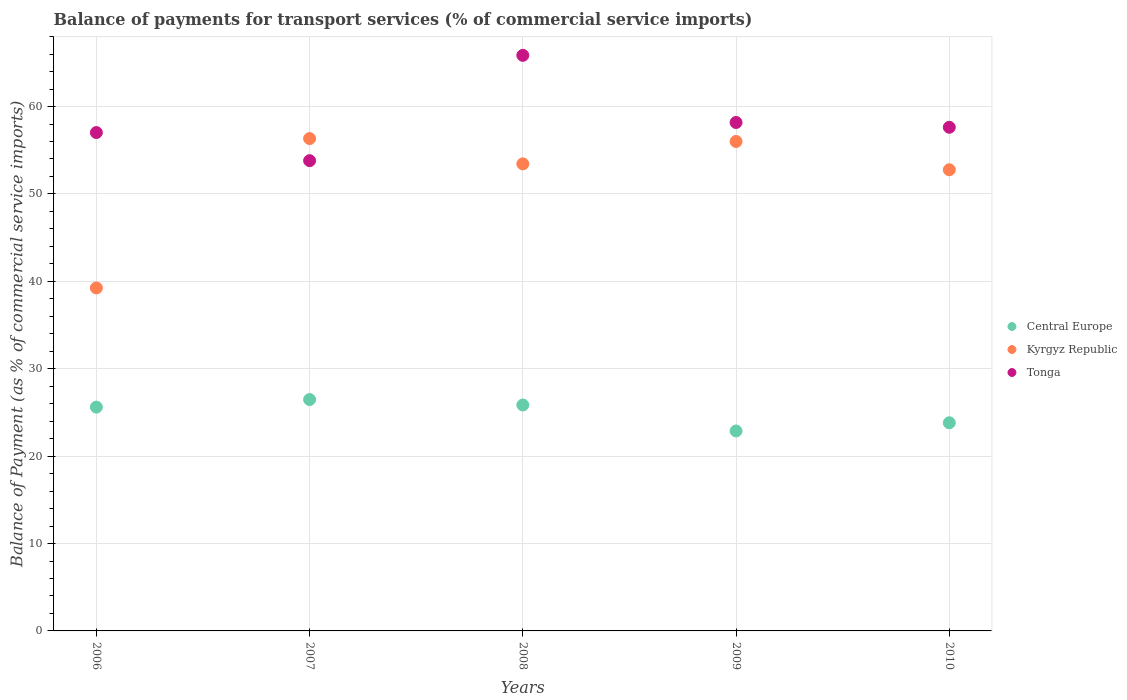How many different coloured dotlines are there?
Ensure brevity in your answer.  3. What is the balance of payments for transport services in Kyrgyz Republic in 2007?
Your answer should be compact. 56.33. Across all years, what is the maximum balance of payments for transport services in Tonga?
Your response must be concise. 65.86. Across all years, what is the minimum balance of payments for transport services in Central Europe?
Offer a very short reply. 22.88. What is the total balance of payments for transport services in Kyrgyz Republic in the graph?
Keep it short and to the point. 257.79. What is the difference between the balance of payments for transport services in Kyrgyz Republic in 2008 and that in 2010?
Give a very brief answer. 0.68. What is the difference between the balance of payments for transport services in Kyrgyz Republic in 2008 and the balance of payments for transport services in Central Europe in 2009?
Offer a terse response. 30.56. What is the average balance of payments for transport services in Central Europe per year?
Ensure brevity in your answer.  24.93. In the year 2009, what is the difference between the balance of payments for transport services in Kyrgyz Republic and balance of payments for transport services in Central Europe?
Keep it short and to the point. 33.13. In how many years, is the balance of payments for transport services in Central Europe greater than 32 %?
Keep it short and to the point. 0. What is the ratio of the balance of payments for transport services in Tonga in 2007 to that in 2010?
Provide a short and direct response. 0.93. What is the difference between the highest and the second highest balance of payments for transport services in Central Europe?
Your answer should be compact. 0.62. What is the difference between the highest and the lowest balance of payments for transport services in Kyrgyz Republic?
Keep it short and to the point. 17.09. In how many years, is the balance of payments for transport services in Kyrgyz Republic greater than the average balance of payments for transport services in Kyrgyz Republic taken over all years?
Provide a short and direct response. 4. Is it the case that in every year, the sum of the balance of payments for transport services in Tonga and balance of payments for transport services in Central Europe  is greater than the balance of payments for transport services in Kyrgyz Republic?
Make the answer very short. Yes. Does the balance of payments for transport services in Tonga monotonically increase over the years?
Offer a terse response. No. Is the balance of payments for transport services in Kyrgyz Republic strictly greater than the balance of payments for transport services in Central Europe over the years?
Provide a succinct answer. Yes. Is the balance of payments for transport services in Kyrgyz Republic strictly less than the balance of payments for transport services in Central Europe over the years?
Offer a very short reply. No. What is the difference between two consecutive major ticks on the Y-axis?
Make the answer very short. 10. Are the values on the major ticks of Y-axis written in scientific E-notation?
Offer a very short reply. No. Does the graph contain any zero values?
Your answer should be very brief. No. Does the graph contain grids?
Keep it short and to the point. Yes. How are the legend labels stacked?
Provide a succinct answer. Vertical. What is the title of the graph?
Offer a terse response. Balance of payments for transport services (% of commercial service imports). Does "North America" appear as one of the legend labels in the graph?
Your answer should be very brief. No. What is the label or title of the X-axis?
Give a very brief answer. Years. What is the label or title of the Y-axis?
Provide a short and direct response. Balance of Payment (as % of commercial service imports). What is the Balance of Payment (as % of commercial service imports) of Central Europe in 2006?
Your answer should be compact. 25.61. What is the Balance of Payment (as % of commercial service imports) of Kyrgyz Republic in 2006?
Provide a short and direct response. 39.24. What is the Balance of Payment (as % of commercial service imports) of Tonga in 2006?
Provide a succinct answer. 57.02. What is the Balance of Payment (as % of commercial service imports) in Central Europe in 2007?
Keep it short and to the point. 26.47. What is the Balance of Payment (as % of commercial service imports) in Kyrgyz Republic in 2007?
Keep it short and to the point. 56.33. What is the Balance of Payment (as % of commercial service imports) of Tonga in 2007?
Provide a succinct answer. 53.81. What is the Balance of Payment (as % of commercial service imports) of Central Europe in 2008?
Ensure brevity in your answer.  25.85. What is the Balance of Payment (as % of commercial service imports) of Kyrgyz Republic in 2008?
Your answer should be very brief. 53.44. What is the Balance of Payment (as % of commercial service imports) of Tonga in 2008?
Give a very brief answer. 65.86. What is the Balance of Payment (as % of commercial service imports) in Central Europe in 2009?
Provide a short and direct response. 22.88. What is the Balance of Payment (as % of commercial service imports) in Kyrgyz Republic in 2009?
Offer a terse response. 56. What is the Balance of Payment (as % of commercial service imports) of Tonga in 2009?
Give a very brief answer. 58.18. What is the Balance of Payment (as % of commercial service imports) in Central Europe in 2010?
Ensure brevity in your answer.  23.82. What is the Balance of Payment (as % of commercial service imports) in Kyrgyz Republic in 2010?
Keep it short and to the point. 52.77. What is the Balance of Payment (as % of commercial service imports) of Tonga in 2010?
Your answer should be compact. 57.63. Across all years, what is the maximum Balance of Payment (as % of commercial service imports) of Central Europe?
Give a very brief answer. 26.47. Across all years, what is the maximum Balance of Payment (as % of commercial service imports) of Kyrgyz Republic?
Offer a very short reply. 56.33. Across all years, what is the maximum Balance of Payment (as % of commercial service imports) in Tonga?
Ensure brevity in your answer.  65.86. Across all years, what is the minimum Balance of Payment (as % of commercial service imports) in Central Europe?
Make the answer very short. 22.88. Across all years, what is the minimum Balance of Payment (as % of commercial service imports) in Kyrgyz Republic?
Ensure brevity in your answer.  39.24. Across all years, what is the minimum Balance of Payment (as % of commercial service imports) of Tonga?
Provide a succinct answer. 53.81. What is the total Balance of Payment (as % of commercial service imports) in Central Europe in the graph?
Offer a terse response. 124.63. What is the total Balance of Payment (as % of commercial service imports) of Kyrgyz Republic in the graph?
Your answer should be compact. 257.79. What is the total Balance of Payment (as % of commercial service imports) in Tonga in the graph?
Keep it short and to the point. 292.49. What is the difference between the Balance of Payment (as % of commercial service imports) in Central Europe in 2006 and that in 2007?
Ensure brevity in your answer.  -0.87. What is the difference between the Balance of Payment (as % of commercial service imports) in Kyrgyz Republic in 2006 and that in 2007?
Keep it short and to the point. -17.09. What is the difference between the Balance of Payment (as % of commercial service imports) of Tonga in 2006 and that in 2007?
Ensure brevity in your answer.  3.22. What is the difference between the Balance of Payment (as % of commercial service imports) of Central Europe in 2006 and that in 2008?
Give a very brief answer. -0.24. What is the difference between the Balance of Payment (as % of commercial service imports) of Kyrgyz Republic in 2006 and that in 2008?
Your answer should be very brief. -14.2. What is the difference between the Balance of Payment (as % of commercial service imports) in Tonga in 2006 and that in 2008?
Offer a terse response. -8.83. What is the difference between the Balance of Payment (as % of commercial service imports) of Central Europe in 2006 and that in 2009?
Give a very brief answer. 2.73. What is the difference between the Balance of Payment (as % of commercial service imports) in Kyrgyz Republic in 2006 and that in 2009?
Your response must be concise. -16.76. What is the difference between the Balance of Payment (as % of commercial service imports) of Tonga in 2006 and that in 2009?
Your answer should be compact. -1.15. What is the difference between the Balance of Payment (as % of commercial service imports) of Central Europe in 2006 and that in 2010?
Offer a terse response. 1.79. What is the difference between the Balance of Payment (as % of commercial service imports) of Kyrgyz Republic in 2006 and that in 2010?
Keep it short and to the point. -13.52. What is the difference between the Balance of Payment (as % of commercial service imports) of Tonga in 2006 and that in 2010?
Make the answer very short. -0.6. What is the difference between the Balance of Payment (as % of commercial service imports) in Central Europe in 2007 and that in 2008?
Your answer should be very brief. 0.62. What is the difference between the Balance of Payment (as % of commercial service imports) in Kyrgyz Republic in 2007 and that in 2008?
Offer a very short reply. 2.89. What is the difference between the Balance of Payment (as % of commercial service imports) of Tonga in 2007 and that in 2008?
Offer a very short reply. -12.05. What is the difference between the Balance of Payment (as % of commercial service imports) in Central Europe in 2007 and that in 2009?
Offer a very short reply. 3.6. What is the difference between the Balance of Payment (as % of commercial service imports) in Kyrgyz Republic in 2007 and that in 2009?
Your response must be concise. 0.33. What is the difference between the Balance of Payment (as % of commercial service imports) in Tonga in 2007 and that in 2009?
Offer a very short reply. -4.37. What is the difference between the Balance of Payment (as % of commercial service imports) in Central Europe in 2007 and that in 2010?
Your answer should be very brief. 2.66. What is the difference between the Balance of Payment (as % of commercial service imports) in Kyrgyz Republic in 2007 and that in 2010?
Offer a terse response. 3.57. What is the difference between the Balance of Payment (as % of commercial service imports) of Tonga in 2007 and that in 2010?
Your answer should be compact. -3.82. What is the difference between the Balance of Payment (as % of commercial service imports) in Central Europe in 2008 and that in 2009?
Your answer should be very brief. 2.97. What is the difference between the Balance of Payment (as % of commercial service imports) of Kyrgyz Republic in 2008 and that in 2009?
Give a very brief answer. -2.56. What is the difference between the Balance of Payment (as % of commercial service imports) of Tonga in 2008 and that in 2009?
Ensure brevity in your answer.  7.68. What is the difference between the Balance of Payment (as % of commercial service imports) of Central Europe in 2008 and that in 2010?
Offer a terse response. 2.04. What is the difference between the Balance of Payment (as % of commercial service imports) in Kyrgyz Republic in 2008 and that in 2010?
Your answer should be very brief. 0.68. What is the difference between the Balance of Payment (as % of commercial service imports) in Tonga in 2008 and that in 2010?
Provide a succinct answer. 8.23. What is the difference between the Balance of Payment (as % of commercial service imports) of Central Europe in 2009 and that in 2010?
Your answer should be very brief. -0.94. What is the difference between the Balance of Payment (as % of commercial service imports) of Kyrgyz Republic in 2009 and that in 2010?
Keep it short and to the point. 3.24. What is the difference between the Balance of Payment (as % of commercial service imports) in Tonga in 2009 and that in 2010?
Offer a very short reply. 0.55. What is the difference between the Balance of Payment (as % of commercial service imports) of Central Europe in 2006 and the Balance of Payment (as % of commercial service imports) of Kyrgyz Republic in 2007?
Your answer should be very brief. -30.73. What is the difference between the Balance of Payment (as % of commercial service imports) of Central Europe in 2006 and the Balance of Payment (as % of commercial service imports) of Tonga in 2007?
Your response must be concise. -28.2. What is the difference between the Balance of Payment (as % of commercial service imports) in Kyrgyz Republic in 2006 and the Balance of Payment (as % of commercial service imports) in Tonga in 2007?
Your answer should be compact. -14.56. What is the difference between the Balance of Payment (as % of commercial service imports) in Central Europe in 2006 and the Balance of Payment (as % of commercial service imports) in Kyrgyz Republic in 2008?
Ensure brevity in your answer.  -27.83. What is the difference between the Balance of Payment (as % of commercial service imports) in Central Europe in 2006 and the Balance of Payment (as % of commercial service imports) in Tonga in 2008?
Make the answer very short. -40.25. What is the difference between the Balance of Payment (as % of commercial service imports) of Kyrgyz Republic in 2006 and the Balance of Payment (as % of commercial service imports) of Tonga in 2008?
Offer a terse response. -26.61. What is the difference between the Balance of Payment (as % of commercial service imports) of Central Europe in 2006 and the Balance of Payment (as % of commercial service imports) of Kyrgyz Republic in 2009?
Make the answer very short. -30.39. What is the difference between the Balance of Payment (as % of commercial service imports) in Central Europe in 2006 and the Balance of Payment (as % of commercial service imports) in Tonga in 2009?
Provide a short and direct response. -32.57. What is the difference between the Balance of Payment (as % of commercial service imports) of Kyrgyz Republic in 2006 and the Balance of Payment (as % of commercial service imports) of Tonga in 2009?
Give a very brief answer. -18.93. What is the difference between the Balance of Payment (as % of commercial service imports) of Central Europe in 2006 and the Balance of Payment (as % of commercial service imports) of Kyrgyz Republic in 2010?
Provide a short and direct response. -27.16. What is the difference between the Balance of Payment (as % of commercial service imports) of Central Europe in 2006 and the Balance of Payment (as % of commercial service imports) of Tonga in 2010?
Provide a succinct answer. -32.02. What is the difference between the Balance of Payment (as % of commercial service imports) in Kyrgyz Republic in 2006 and the Balance of Payment (as % of commercial service imports) in Tonga in 2010?
Make the answer very short. -18.38. What is the difference between the Balance of Payment (as % of commercial service imports) in Central Europe in 2007 and the Balance of Payment (as % of commercial service imports) in Kyrgyz Republic in 2008?
Keep it short and to the point. -26.97. What is the difference between the Balance of Payment (as % of commercial service imports) of Central Europe in 2007 and the Balance of Payment (as % of commercial service imports) of Tonga in 2008?
Your answer should be compact. -39.38. What is the difference between the Balance of Payment (as % of commercial service imports) in Kyrgyz Republic in 2007 and the Balance of Payment (as % of commercial service imports) in Tonga in 2008?
Keep it short and to the point. -9.52. What is the difference between the Balance of Payment (as % of commercial service imports) in Central Europe in 2007 and the Balance of Payment (as % of commercial service imports) in Kyrgyz Republic in 2009?
Ensure brevity in your answer.  -29.53. What is the difference between the Balance of Payment (as % of commercial service imports) of Central Europe in 2007 and the Balance of Payment (as % of commercial service imports) of Tonga in 2009?
Make the answer very short. -31.7. What is the difference between the Balance of Payment (as % of commercial service imports) in Kyrgyz Republic in 2007 and the Balance of Payment (as % of commercial service imports) in Tonga in 2009?
Ensure brevity in your answer.  -1.84. What is the difference between the Balance of Payment (as % of commercial service imports) of Central Europe in 2007 and the Balance of Payment (as % of commercial service imports) of Kyrgyz Republic in 2010?
Offer a terse response. -26.29. What is the difference between the Balance of Payment (as % of commercial service imports) of Central Europe in 2007 and the Balance of Payment (as % of commercial service imports) of Tonga in 2010?
Your answer should be compact. -31.15. What is the difference between the Balance of Payment (as % of commercial service imports) of Kyrgyz Republic in 2007 and the Balance of Payment (as % of commercial service imports) of Tonga in 2010?
Provide a short and direct response. -1.29. What is the difference between the Balance of Payment (as % of commercial service imports) in Central Europe in 2008 and the Balance of Payment (as % of commercial service imports) in Kyrgyz Republic in 2009?
Offer a terse response. -30.15. What is the difference between the Balance of Payment (as % of commercial service imports) in Central Europe in 2008 and the Balance of Payment (as % of commercial service imports) in Tonga in 2009?
Your answer should be compact. -32.33. What is the difference between the Balance of Payment (as % of commercial service imports) in Kyrgyz Republic in 2008 and the Balance of Payment (as % of commercial service imports) in Tonga in 2009?
Provide a succinct answer. -4.73. What is the difference between the Balance of Payment (as % of commercial service imports) of Central Europe in 2008 and the Balance of Payment (as % of commercial service imports) of Kyrgyz Republic in 2010?
Your answer should be very brief. -26.91. What is the difference between the Balance of Payment (as % of commercial service imports) in Central Europe in 2008 and the Balance of Payment (as % of commercial service imports) in Tonga in 2010?
Offer a terse response. -31.78. What is the difference between the Balance of Payment (as % of commercial service imports) of Kyrgyz Republic in 2008 and the Balance of Payment (as % of commercial service imports) of Tonga in 2010?
Provide a short and direct response. -4.18. What is the difference between the Balance of Payment (as % of commercial service imports) of Central Europe in 2009 and the Balance of Payment (as % of commercial service imports) of Kyrgyz Republic in 2010?
Ensure brevity in your answer.  -29.89. What is the difference between the Balance of Payment (as % of commercial service imports) of Central Europe in 2009 and the Balance of Payment (as % of commercial service imports) of Tonga in 2010?
Ensure brevity in your answer.  -34.75. What is the difference between the Balance of Payment (as % of commercial service imports) of Kyrgyz Republic in 2009 and the Balance of Payment (as % of commercial service imports) of Tonga in 2010?
Provide a short and direct response. -1.62. What is the average Balance of Payment (as % of commercial service imports) of Central Europe per year?
Your response must be concise. 24.93. What is the average Balance of Payment (as % of commercial service imports) in Kyrgyz Republic per year?
Keep it short and to the point. 51.56. What is the average Balance of Payment (as % of commercial service imports) of Tonga per year?
Ensure brevity in your answer.  58.5. In the year 2006, what is the difference between the Balance of Payment (as % of commercial service imports) in Central Europe and Balance of Payment (as % of commercial service imports) in Kyrgyz Republic?
Provide a succinct answer. -13.64. In the year 2006, what is the difference between the Balance of Payment (as % of commercial service imports) in Central Europe and Balance of Payment (as % of commercial service imports) in Tonga?
Your answer should be compact. -31.42. In the year 2006, what is the difference between the Balance of Payment (as % of commercial service imports) of Kyrgyz Republic and Balance of Payment (as % of commercial service imports) of Tonga?
Ensure brevity in your answer.  -17.78. In the year 2007, what is the difference between the Balance of Payment (as % of commercial service imports) in Central Europe and Balance of Payment (as % of commercial service imports) in Kyrgyz Republic?
Ensure brevity in your answer.  -29.86. In the year 2007, what is the difference between the Balance of Payment (as % of commercial service imports) in Central Europe and Balance of Payment (as % of commercial service imports) in Tonga?
Your answer should be very brief. -27.33. In the year 2007, what is the difference between the Balance of Payment (as % of commercial service imports) in Kyrgyz Republic and Balance of Payment (as % of commercial service imports) in Tonga?
Offer a terse response. 2.53. In the year 2008, what is the difference between the Balance of Payment (as % of commercial service imports) of Central Europe and Balance of Payment (as % of commercial service imports) of Kyrgyz Republic?
Provide a succinct answer. -27.59. In the year 2008, what is the difference between the Balance of Payment (as % of commercial service imports) in Central Europe and Balance of Payment (as % of commercial service imports) in Tonga?
Give a very brief answer. -40.01. In the year 2008, what is the difference between the Balance of Payment (as % of commercial service imports) in Kyrgyz Republic and Balance of Payment (as % of commercial service imports) in Tonga?
Ensure brevity in your answer.  -12.41. In the year 2009, what is the difference between the Balance of Payment (as % of commercial service imports) of Central Europe and Balance of Payment (as % of commercial service imports) of Kyrgyz Republic?
Keep it short and to the point. -33.13. In the year 2009, what is the difference between the Balance of Payment (as % of commercial service imports) in Central Europe and Balance of Payment (as % of commercial service imports) in Tonga?
Give a very brief answer. -35.3. In the year 2009, what is the difference between the Balance of Payment (as % of commercial service imports) in Kyrgyz Republic and Balance of Payment (as % of commercial service imports) in Tonga?
Offer a very short reply. -2.17. In the year 2010, what is the difference between the Balance of Payment (as % of commercial service imports) of Central Europe and Balance of Payment (as % of commercial service imports) of Kyrgyz Republic?
Make the answer very short. -28.95. In the year 2010, what is the difference between the Balance of Payment (as % of commercial service imports) in Central Europe and Balance of Payment (as % of commercial service imports) in Tonga?
Ensure brevity in your answer.  -33.81. In the year 2010, what is the difference between the Balance of Payment (as % of commercial service imports) in Kyrgyz Republic and Balance of Payment (as % of commercial service imports) in Tonga?
Make the answer very short. -4.86. What is the ratio of the Balance of Payment (as % of commercial service imports) of Central Europe in 2006 to that in 2007?
Give a very brief answer. 0.97. What is the ratio of the Balance of Payment (as % of commercial service imports) of Kyrgyz Republic in 2006 to that in 2007?
Ensure brevity in your answer.  0.7. What is the ratio of the Balance of Payment (as % of commercial service imports) in Tonga in 2006 to that in 2007?
Keep it short and to the point. 1.06. What is the ratio of the Balance of Payment (as % of commercial service imports) in Central Europe in 2006 to that in 2008?
Your answer should be compact. 0.99. What is the ratio of the Balance of Payment (as % of commercial service imports) of Kyrgyz Republic in 2006 to that in 2008?
Keep it short and to the point. 0.73. What is the ratio of the Balance of Payment (as % of commercial service imports) in Tonga in 2006 to that in 2008?
Provide a succinct answer. 0.87. What is the ratio of the Balance of Payment (as % of commercial service imports) in Central Europe in 2006 to that in 2009?
Your response must be concise. 1.12. What is the ratio of the Balance of Payment (as % of commercial service imports) of Kyrgyz Republic in 2006 to that in 2009?
Ensure brevity in your answer.  0.7. What is the ratio of the Balance of Payment (as % of commercial service imports) in Tonga in 2006 to that in 2009?
Offer a terse response. 0.98. What is the ratio of the Balance of Payment (as % of commercial service imports) in Central Europe in 2006 to that in 2010?
Your answer should be very brief. 1.08. What is the ratio of the Balance of Payment (as % of commercial service imports) of Kyrgyz Republic in 2006 to that in 2010?
Your answer should be compact. 0.74. What is the ratio of the Balance of Payment (as % of commercial service imports) in Tonga in 2006 to that in 2010?
Your answer should be very brief. 0.99. What is the ratio of the Balance of Payment (as % of commercial service imports) of Central Europe in 2007 to that in 2008?
Your answer should be very brief. 1.02. What is the ratio of the Balance of Payment (as % of commercial service imports) in Kyrgyz Republic in 2007 to that in 2008?
Your response must be concise. 1.05. What is the ratio of the Balance of Payment (as % of commercial service imports) in Tonga in 2007 to that in 2008?
Offer a terse response. 0.82. What is the ratio of the Balance of Payment (as % of commercial service imports) of Central Europe in 2007 to that in 2009?
Provide a succinct answer. 1.16. What is the ratio of the Balance of Payment (as % of commercial service imports) in Kyrgyz Republic in 2007 to that in 2009?
Your answer should be compact. 1.01. What is the ratio of the Balance of Payment (as % of commercial service imports) of Tonga in 2007 to that in 2009?
Offer a very short reply. 0.92. What is the ratio of the Balance of Payment (as % of commercial service imports) of Central Europe in 2007 to that in 2010?
Ensure brevity in your answer.  1.11. What is the ratio of the Balance of Payment (as % of commercial service imports) of Kyrgyz Republic in 2007 to that in 2010?
Ensure brevity in your answer.  1.07. What is the ratio of the Balance of Payment (as % of commercial service imports) of Tonga in 2007 to that in 2010?
Your answer should be very brief. 0.93. What is the ratio of the Balance of Payment (as % of commercial service imports) of Central Europe in 2008 to that in 2009?
Your response must be concise. 1.13. What is the ratio of the Balance of Payment (as % of commercial service imports) in Kyrgyz Republic in 2008 to that in 2009?
Your answer should be compact. 0.95. What is the ratio of the Balance of Payment (as % of commercial service imports) in Tonga in 2008 to that in 2009?
Offer a very short reply. 1.13. What is the ratio of the Balance of Payment (as % of commercial service imports) of Central Europe in 2008 to that in 2010?
Your answer should be very brief. 1.09. What is the ratio of the Balance of Payment (as % of commercial service imports) in Kyrgyz Republic in 2008 to that in 2010?
Your response must be concise. 1.01. What is the ratio of the Balance of Payment (as % of commercial service imports) in Tonga in 2008 to that in 2010?
Give a very brief answer. 1.14. What is the ratio of the Balance of Payment (as % of commercial service imports) in Central Europe in 2009 to that in 2010?
Your answer should be compact. 0.96. What is the ratio of the Balance of Payment (as % of commercial service imports) of Kyrgyz Republic in 2009 to that in 2010?
Ensure brevity in your answer.  1.06. What is the ratio of the Balance of Payment (as % of commercial service imports) of Tonga in 2009 to that in 2010?
Your answer should be very brief. 1.01. What is the difference between the highest and the second highest Balance of Payment (as % of commercial service imports) in Central Europe?
Your answer should be very brief. 0.62. What is the difference between the highest and the second highest Balance of Payment (as % of commercial service imports) in Kyrgyz Republic?
Provide a short and direct response. 0.33. What is the difference between the highest and the second highest Balance of Payment (as % of commercial service imports) in Tonga?
Provide a succinct answer. 7.68. What is the difference between the highest and the lowest Balance of Payment (as % of commercial service imports) in Central Europe?
Provide a short and direct response. 3.6. What is the difference between the highest and the lowest Balance of Payment (as % of commercial service imports) in Kyrgyz Republic?
Provide a short and direct response. 17.09. What is the difference between the highest and the lowest Balance of Payment (as % of commercial service imports) in Tonga?
Your response must be concise. 12.05. 